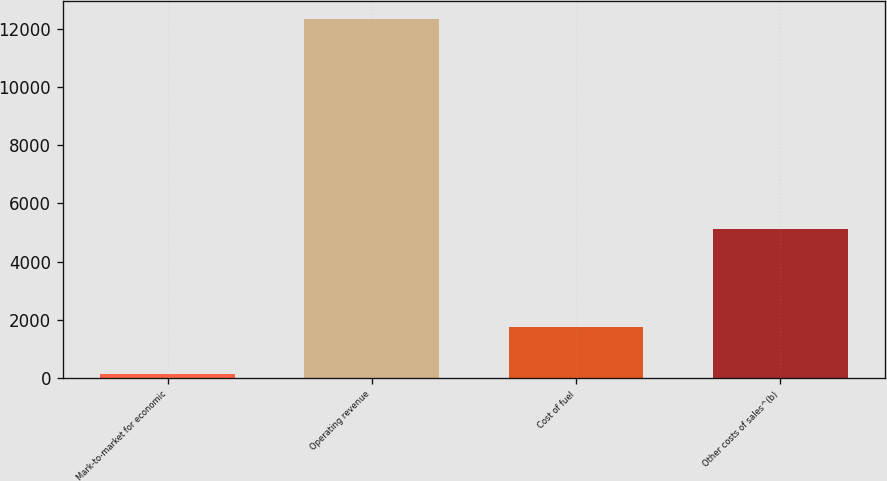<chart> <loc_0><loc_0><loc_500><loc_500><bar_chart><fcel>Mark-to-market for economic<fcel>Operating revenue<fcel>Cost of fuel<fcel>Other costs of sales^(b)<nl><fcel>134<fcel>12328<fcel>1756<fcel>5114<nl></chart> 